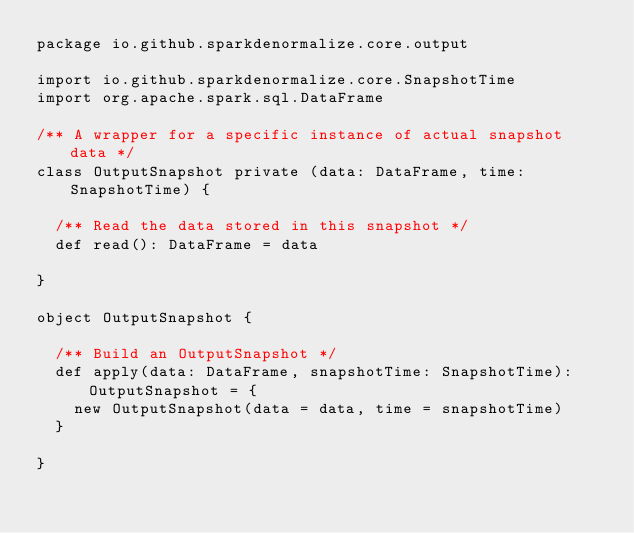Convert code to text. <code><loc_0><loc_0><loc_500><loc_500><_Scala_>package io.github.sparkdenormalize.core.output

import io.github.sparkdenormalize.core.SnapshotTime
import org.apache.spark.sql.DataFrame

/** A wrapper for a specific instance of actual snapshot data */
class OutputSnapshot private (data: DataFrame, time: SnapshotTime) {

  /** Read the data stored in this snapshot */
  def read(): DataFrame = data

}

object OutputSnapshot {

  /** Build an OutputSnapshot */
  def apply(data: DataFrame, snapshotTime: SnapshotTime): OutputSnapshot = {
    new OutputSnapshot(data = data, time = snapshotTime)
  }

}
</code> 